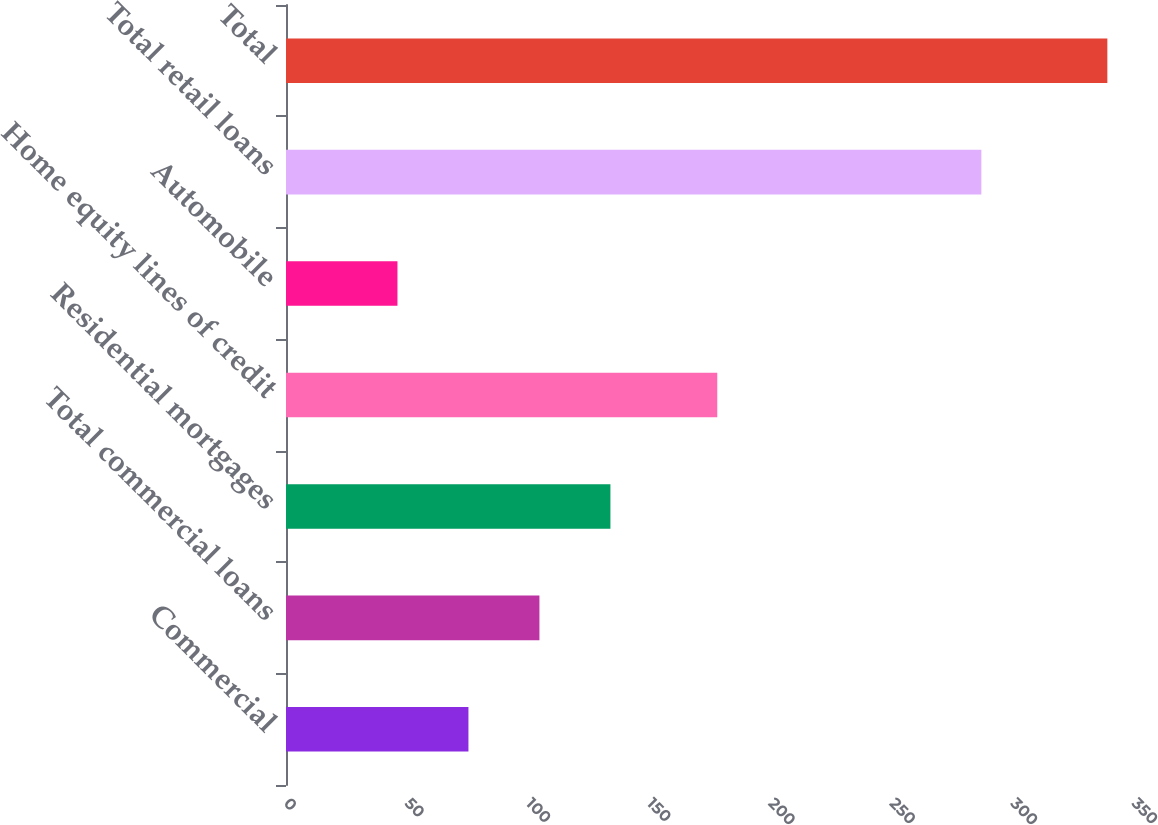Convert chart to OTSL. <chart><loc_0><loc_0><loc_500><loc_500><bar_chart><fcel>Commercial<fcel>Total commercial loans<fcel>Residential mortgages<fcel>Home equity lines of credit<fcel>Automobile<fcel>Total retail loans<fcel>Total<nl><fcel>75.3<fcel>104.6<fcel>133.9<fcel>178<fcel>46<fcel>287<fcel>339<nl></chart> 